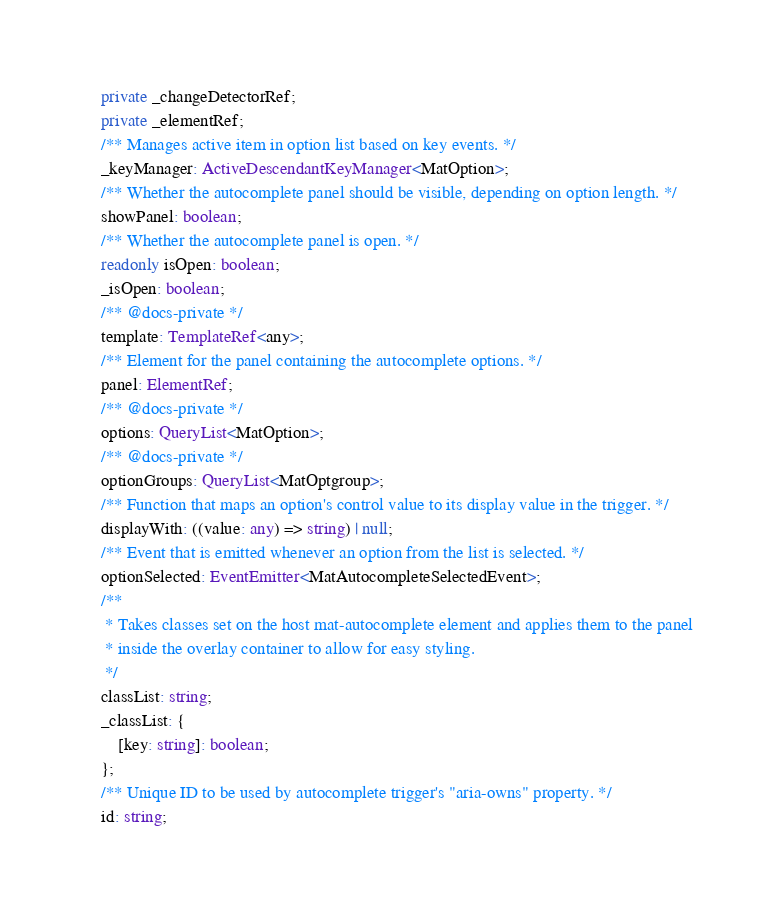Convert code to text. <code><loc_0><loc_0><loc_500><loc_500><_TypeScript_>    private _changeDetectorRef;
    private _elementRef;
    /** Manages active item in option list based on key events. */
    _keyManager: ActiveDescendantKeyManager<MatOption>;
    /** Whether the autocomplete panel should be visible, depending on option length. */
    showPanel: boolean;
    /** Whether the autocomplete panel is open. */
    readonly isOpen: boolean;
    _isOpen: boolean;
    /** @docs-private */
    template: TemplateRef<any>;
    /** Element for the panel containing the autocomplete options. */
    panel: ElementRef;
    /** @docs-private */
    options: QueryList<MatOption>;
    /** @docs-private */
    optionGroups: QueryList<MatOptgroup>;
    /** Function that maps an option's control value to its display value in the trigger. */
    displayWith: ((value: any) => string) | null;
    /** Event that is emitted whenever an option from the list is selected. */
    optionSelected: EventEmitter<MatAutocompleteSelectedEvent>;
    /**
     * Takes classes set on the host mat-autocomplete element and applies them to the panel
     * inside the overlay container to allow for easy styling.
     */
    classList: string;
    _classList: {
        [key: string]: boolean;
    };
    /** Unique ID to be used by autocomplete trigger's "aria-owns" property. */
    id: string;</code> 